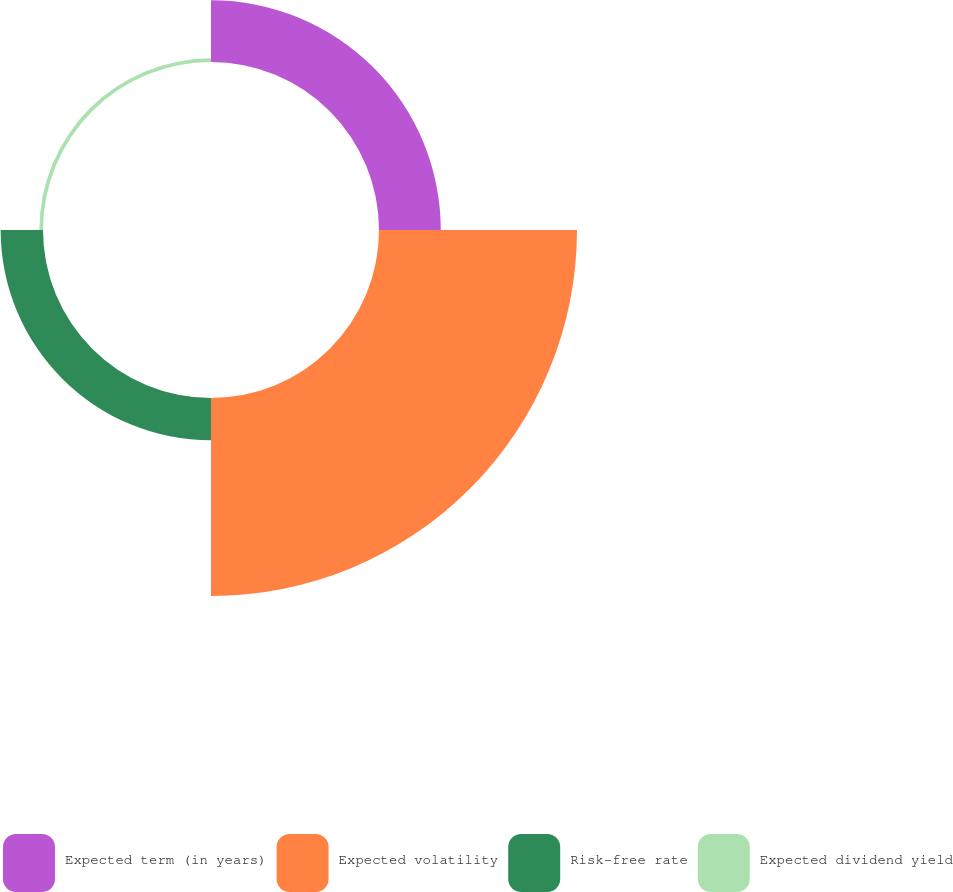<chart> <loc_0><loc_0><loc_500><loc_500><pie_chart><fcel>Expected term (in years)<fcel>Expected volatility<fcel>Risk-free rate<fcel>Expected dividend yield<nl><fcel>20.2%<fcel>64.74%<fcel>13.85%<fcel>1.2%<nl></chart> 